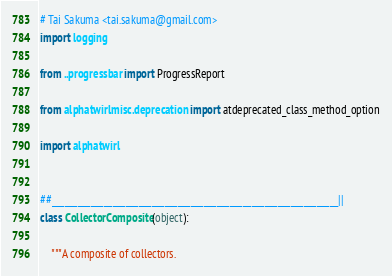Convert code to text. <code><loc_0><loc_0><loc_500><loc_500><_Python_># Tai Sakuma <tai.sakuma@gmail.com>
import logging

from ..progressbar import ProgressReport

from alphatwirl.misc.deprecation import atdeprecated_class_method_option

import alphatwirl


##__________________________________________________________________||
class CollectorComposite(object):

    """A composite of collectors.
</code> 